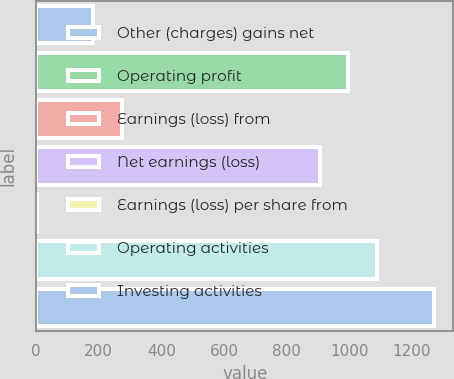Convert chart. <chart><loc_0><loc_0><loc_500><loc_500><bar_chart><fcel>Other (charges) gains net<fcel>Operating profit<fcel>Earnings (loss) from<fcel>Net earnings (loss)<fcel>Earnings (loss) per share from<fcel>Operating activities<fcel>Investing activities<nl><fcel>182.43<fcel>997.56<fcel>273<fcel>906.99<fcel>1.29<fcel>1088.13<fcel>1269.27<nl></chart> 